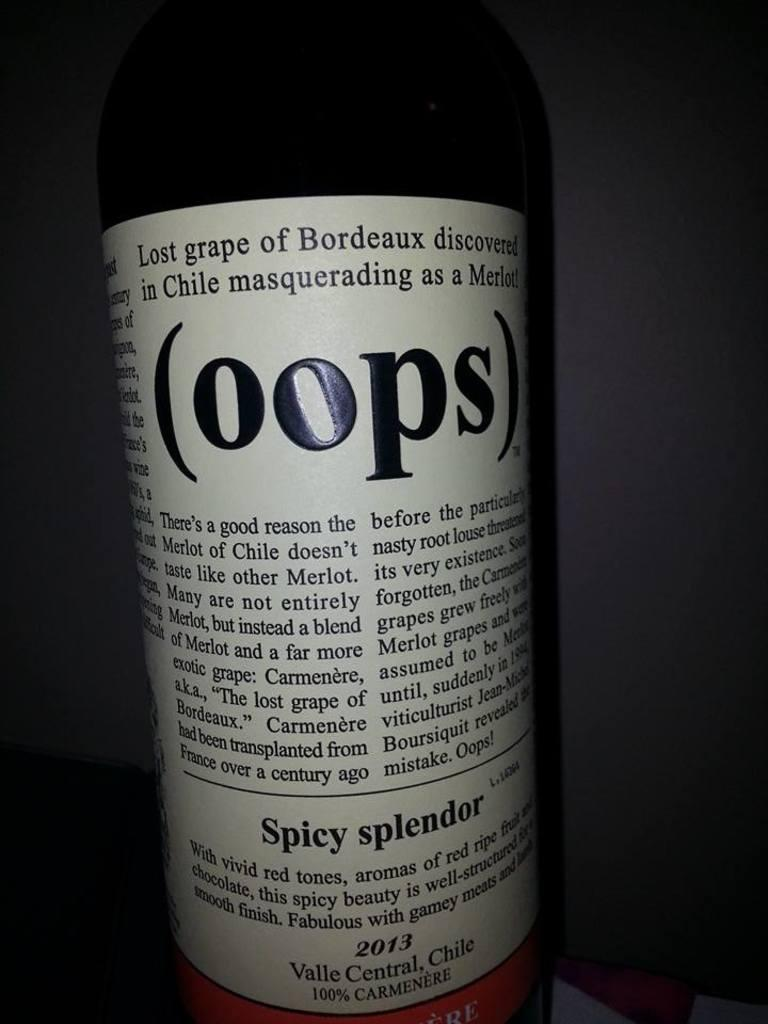<image>
Provide a brief description of the given image. A bottle of oops wine claims spicy splendor. 